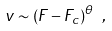Convert formula to latex. <formula><loc_0><loc_0><loc_500><loc_500>v \sim ( F - F _ { c } ) ^ { \theta } \ ,</formula> 